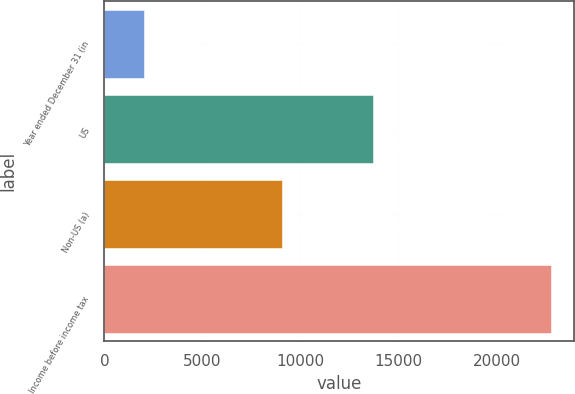Convert chart. <chart><loc_0><loc_0><loc_500><loc_500><bar_chart><fcel>Year ended December 31 (in<fcel>US<fcel>Non-US (a)<fcel>Income before income tax<nl><fcel>2007<fcel>13720<fcel>9085<fcel>22805<nl></chart> 